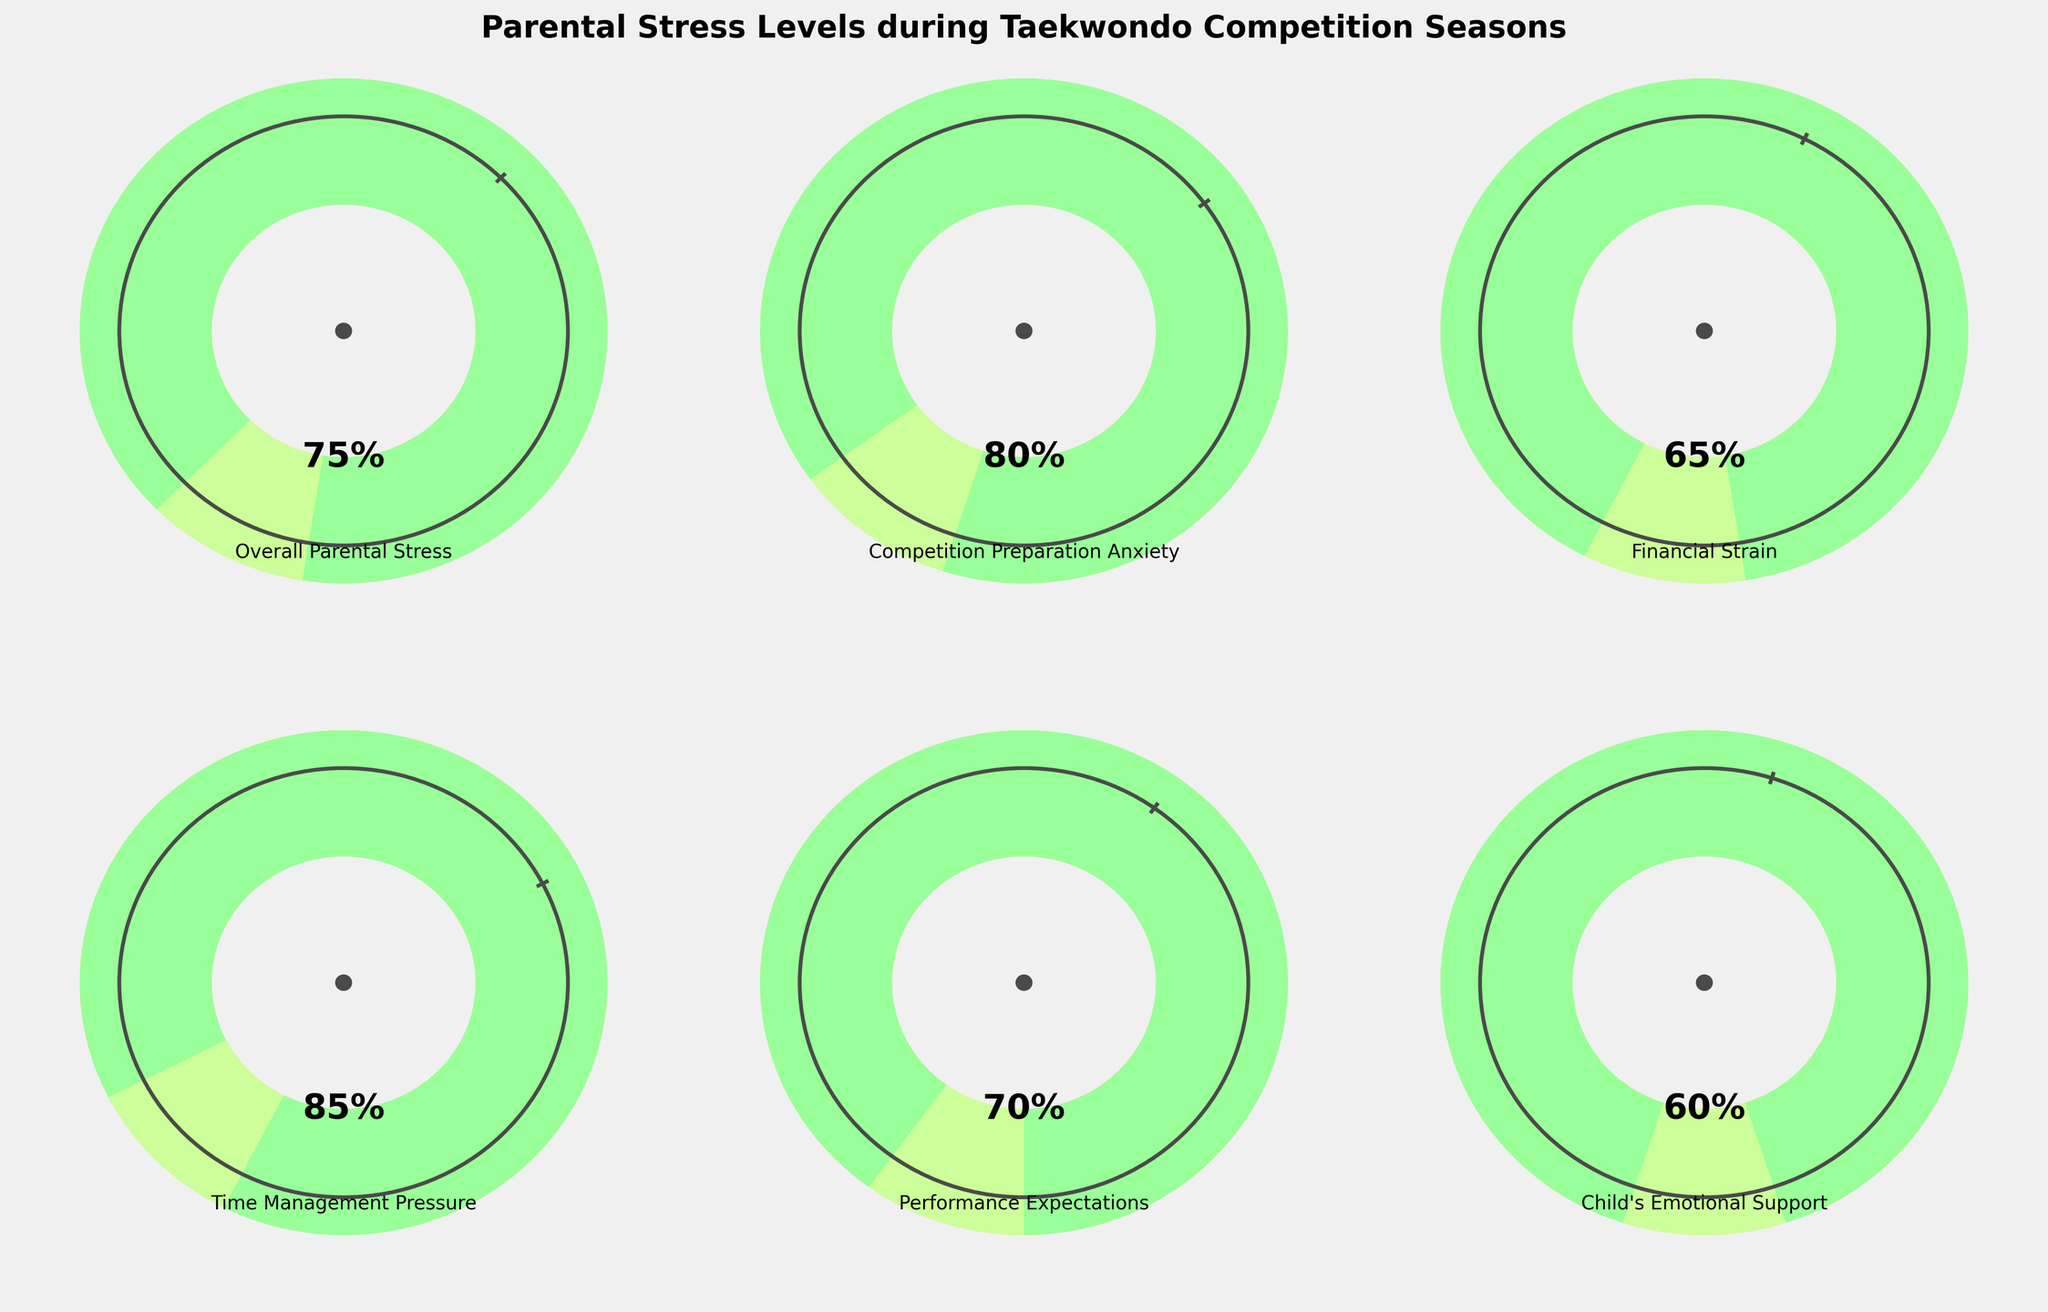What is the overall parental stress level during competition seasons? The overall parental stress level is indicated by the "Overall Parental Stress" gauge, which shows a value.
Answer: 75% Which category has the highest stress level? By comparing the stress levels shown in all the gauges, the highest value can be identified.
Answer: Time Management Pressure How does the financial strain compare to the child's emotional support stress? The Financial Strain gauge shows a value, and the Child's Emotional Support gauge shows another value. Comparing these two values gives the answer.
Answer: Financial Strain is higher (65% vs. 60%) What is the average stress level across all categories? Sum all the stress levels and divide by the number of categories: (75 + 80 + 65 + 85 + 70 + 60) / 6.
Answer: 72.5% What is the difference between competition preparation anxiety and performance expectations? Subtract the smaller value (Performance Expectations) from the larger value (Competition Preparation Anxiety).
Answer: 10% Which category has the lowest stress level? By looking at all the gauges, the one with the lowest value represents the category with the lowest stress level.
Answer: Child's Emotional Support How much higher is the time management pressure compared to the financial strain? Subtract the Financial Strain level from the Time Management Pressure level.
Answer: 20% Are any of the stress levels below 50%? Check all gauge values to see if any are below 50%.
Answer: No How does the competition preparation anxiety compare to the overall parental stress? Compare the values seen directly on the respective gauges for each category.
Answer: Competition Preparation Anxiety is higher (80% vs. 75%) Which two categories have the closest stress levels? Compare the values to find the smallest difference between any two categories.
Answer: Performance Expectations and Child's Emotional Support (difference of 10%) 